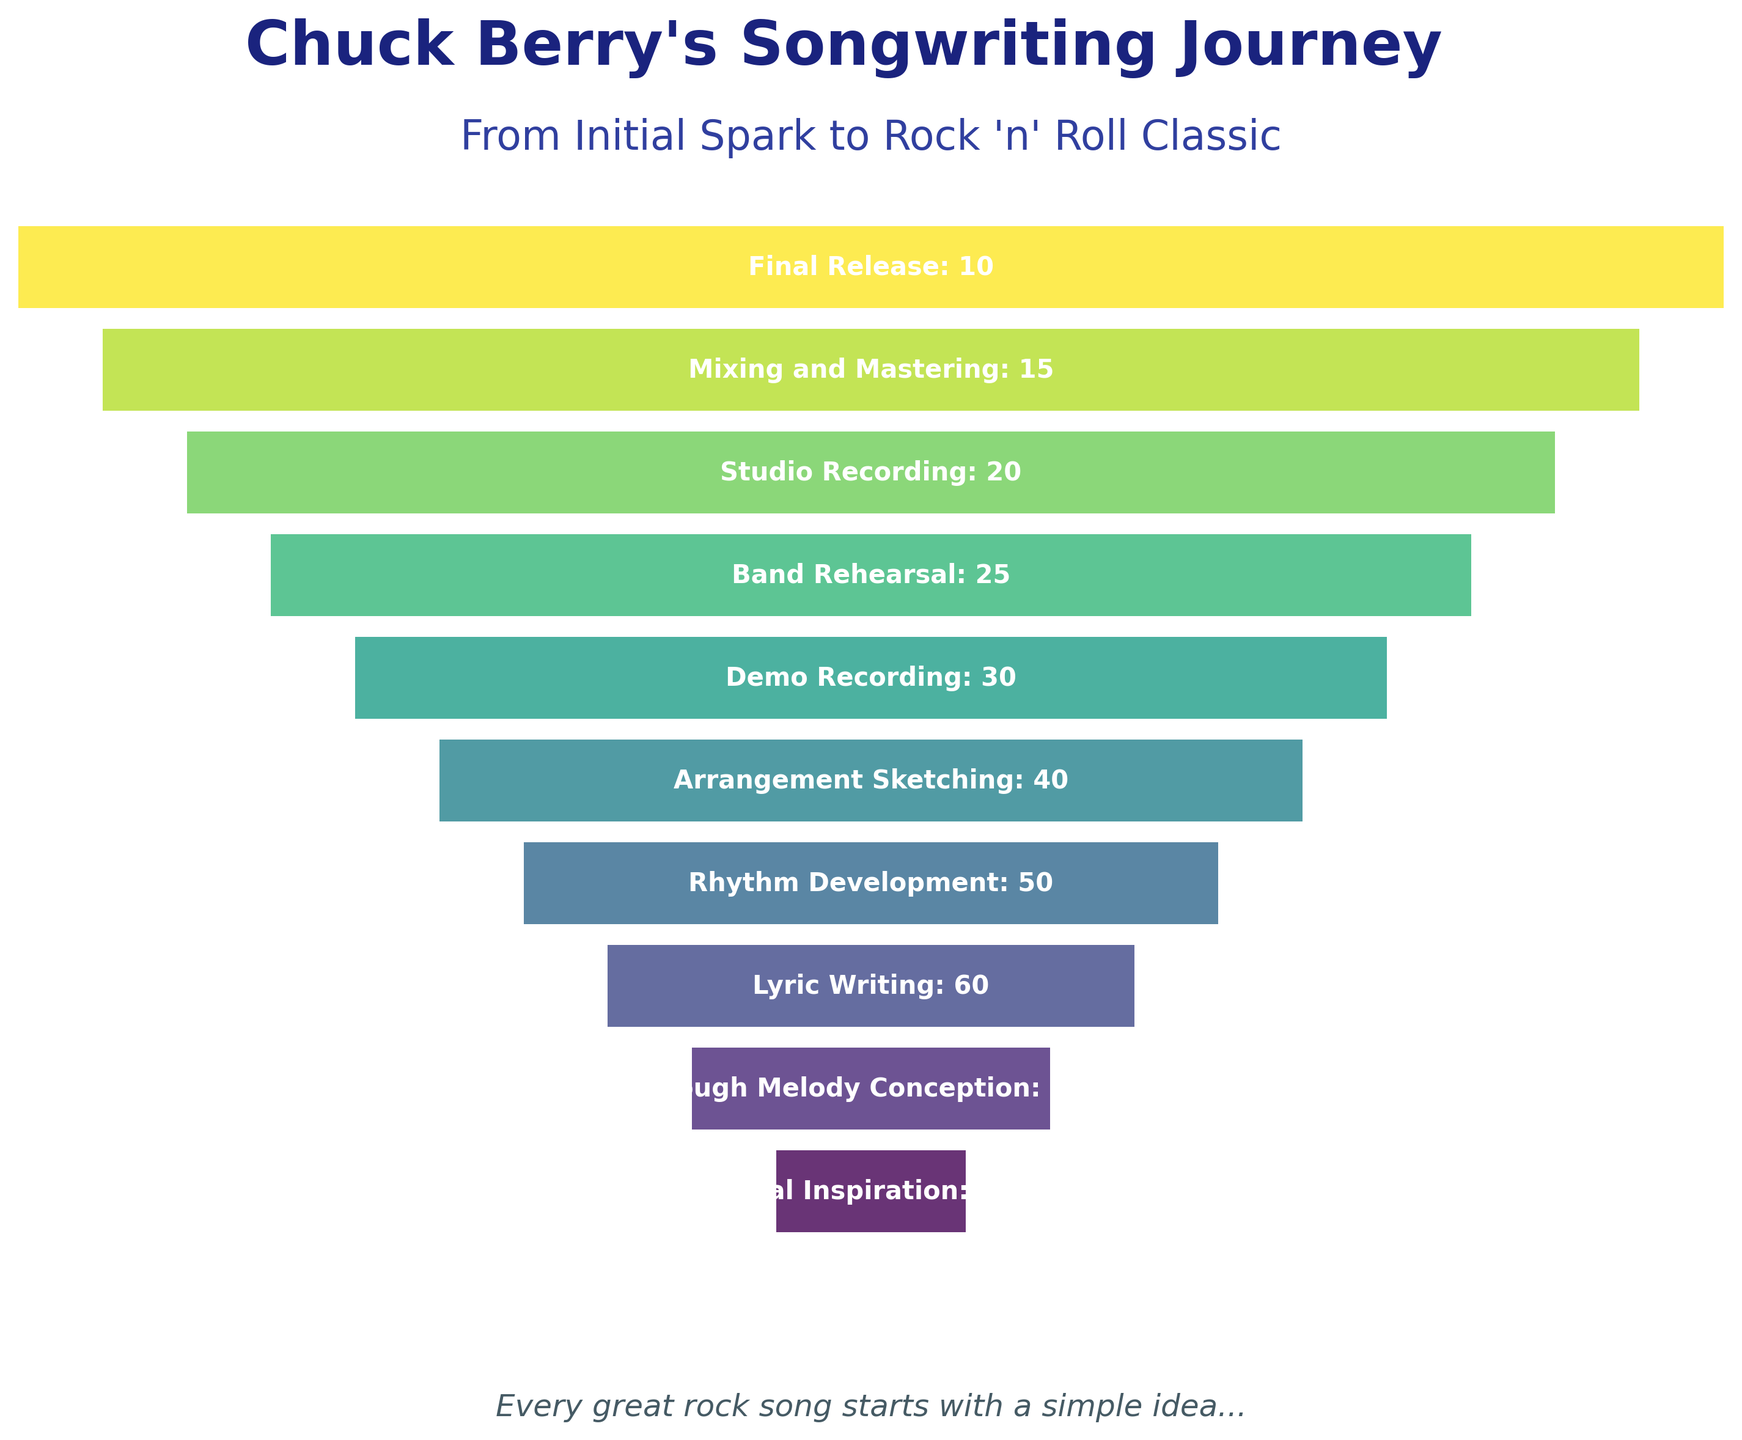what is the title of the figure? The title is at the top of the figure, and it reads "Chuck Berry's Songwriting Journey."
Answer: Chuck Berry's Songwriting Journey What is the highest stage in the funnel chart? The highest stage in a funnel chart is typically at the widest part. In this chart, "Initial Inspiration" is at the top and widest part of the funnel.
Answer: Initial Inspiration Which stage shows 25 songs/ideas? In the funnel chart, 25 songs/ideas are associated with "Band Rehearsal."
Answer: Band Rehearsal How many stages are there in the songwriting process according to the chart? By counting the number of horizontal bars (stages), we see there are 10 stages listed in the funnel chart.
Answer: 10 Which stage has half the number of ideas compared to the Initial Inspiration stage? The Initial Inspiration stage has 100 ideas. Half of that is 50 ideas, which corresponds to the "Rhythm Development" stage.
Answer: Rhythm Development What is the width of the "Lyric Writing" stage relative to the total width? The "Lyric Writing" stage is noted to have about 60 ideas/songs; it is visually about 60% of the total width, considering the decreasing width from top to bottom.
Answer: Approximately 60% Are there more ideas in the "Arrangement Sketching" or the "Studio Recording" stage? Comparing the values, "Arrangement Sketching" has 40 ideas, while "Studio Recording" has 20 ideas. Therefore, "Arrangement Sketching" has more ideas.
Answer: Arrangement Sketching What stage represents the final stage of the songwriting process? The last stage at the bottom of the funnel chart is labeled "Final Release."
Answer: Final Release What is the drop in the number of songs from the "Rough Melody Conception" to the "Band Rehearsal" stage? The "Rough Melody Conception" stage has 75 songs, and the "Band Rehearsal" stage has 25. The drop is calculated as 75 - 25.
Answer: 50 What percentage of the initial ideas make it to the "Mixing and Mastering" stage? "Mixing and Mastering" has 15 songs out of the initial 100 ideas. The percentage is (15 / 100) * 100%.
Answer: 15% 